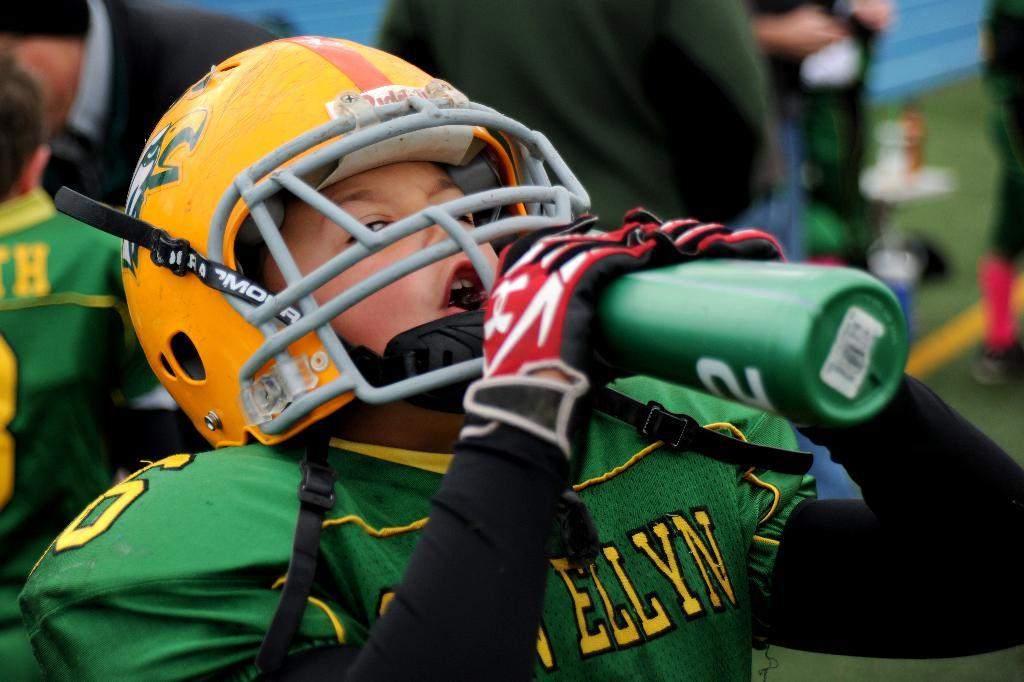How many people are present in the image? There are many people in the image. What is one person doing in the image? A person is drinking water in the image. What is the person wearing while drinking water? The person is wearing a green sports dress. What type of surface is under the people in the image? There is grass on the ground in the image. What organization is the person in the green sports dress representing in the image? There is no information about any organization in the image. What is the weight of the person drinking water in the image? The weight of the person cannot be determined from the image. 